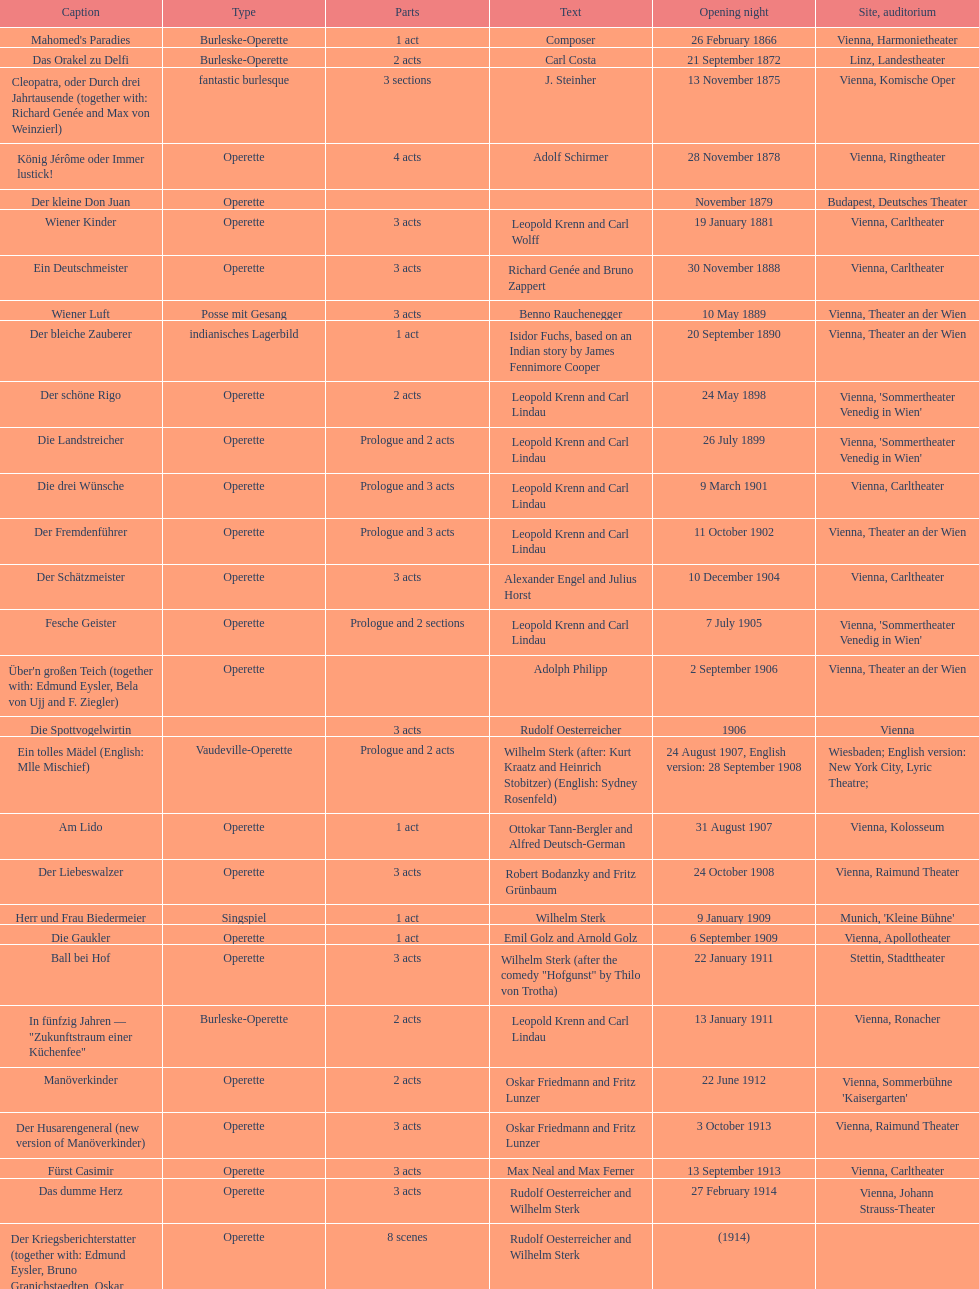Which genre is featured the most in this chart? Operette. Help me parse the entirety of this table. {'header': ['Caption', 'Type', 'Parts', 'Text', 'Opening night', 'Site, auditorium'], 'rows': [["Mahomed's Paradies", 'Burleske-Operette', '1 act', 'Composer', '26 February 1866', 'Vienna, Harmonietheater'], ['Das Orakel zu Delfi', 'Burleske-Operette', '2 acts', 'Carl Costa', '21 September 1872', 'Linz, Landestheater'], ['Cleopatra, oder Durch drei Jahrtausende (together with: Richard Genée and Max von Weinzierl)', 'fantastic burlesque', '3 sections', 'J. Steinher', '13 November 1875', 'Vienna, Komische Oper'], ['König Jérôme oder Immer lustick!', 'Operette', '4 acts', 'Adolf Schirmer', '28 November 1878', 'Vienna, Ringtheater'], ['Der kleine Don Juan', 'Operette', '', '', 'November 1879', 'Budapest, Deutsches Theater'], ['Wiener Kinder', 'Operette', '3 acts', 'Leopold Krenn and Carl Wolff', '19 January 1881', 'Vienna, Carltheater'], ['Ein Deutschmeister', 'Operette', '3 acts', 'Richard Genée and Bruno Zappert', '30 November 1888', 'Vienna, Carltheater'], ['Wiener Luft', 'Posse mit Gesang', '3 acts', 'Benno Rauchenegger', '10 May 1889', 'Vienna, Theater an der Wien'], ['Der bleiche Zauberer', 'indianisches Lagerbild', '1 act', 'Isidor Fuchs, based on an Indian story by James Fennimore Cooper', '20 September 1890', 'Vienna, Theater an der Wien'], ['Der schöne Rigo', 'Operette', '2 acts', 'Leopold Krenn and Carl Lindau', '24 May 1898', "Vienna, 'Sommertheater Venedig in Wien'"], ['Die Landstreicher', 'Operette', 'Prologue and 2 acts', 'Leopold Krenn and Carl Lindau', '26 July 1899', "Vienna, 'Sommertheater Venedig in Wien'"], ['Die drei Wünsche', 'Operette', 'Prologue and 3 acts', 'Leopold Krenn and Carl Lindau', '9 March 1901', 'Vienna, Carltheater'], ['Der Fremdenführer', 'Operette', 'Prologue and 3 acts', 'Leopold Krenn and Carl Lindau', '11 October 1902', 'Vienna, Theater an der Wien'], ['Der Schätzmeister', 'Operette', '3 acts', 'Alexander Engel and Julius Horst', '10 December 1904', 'Vienna, Carltheater'], ['Fesche Geister', 'Operette', 'Prologue and 2 sections', 'Leopold Krenn and Carl Lindau', '7 July 1905', "Vienna, 'Sommertheater Venedig in Wien'"], ["Über'n großen Teich (together with: Edmund Eysler, Bela von Ujj and F. Ziegler)", 'Operette', '', 'Adolph Philipp', '2 September 1906', 'Vienna, Theater an der Wien'], ['Die Spottvogelwirtin', '', '3 acts', 'Rudolf Oesterreicher', '1906', 'Vienna'], ['Ein tolles Mädel (English: Mlle Mischief)', 'Vaudeville-Operette', 'Prologue and 2 acts', 'Wilhelm Sterk (after: Kurt Kraatz and Heinrich Stobitzer) (English: Sydney Rosenfeld)', '24 August 1907, English version: 28 September 1908', 'Wiesbaden; English version: New York City, Lyric Theatre;'], ['Am Lido', 'Operette', '1 act', 'Ottokar Tann-Bergler and Alfred Deutsch-German', '31 August 1907', 'Vienna, Kolosseum'], ['Der Liebeswalzer', 'Operette', '3 acts', 'Robert Bodanzky and Fritz Grünbaum', '24 October 1908', 'Vienna, Raimund Theater'], ['Herr und Frau Biedermeier', 'Singspiel', '1 act', 'Wilhelm Sterk', '9 January 1909', "Munich, 'Kleine Bühne'"], ['Die Gaukler', 'Operette', '1 act', 'Emil Golz and Arnold Golz', '6 September 1909', 'Vienna, Apollotheater'], ['Ball bei Hof', 'Operette', '3 acts', 'Wilhelm Sterk (after the comedy "Hofgunst" by Thilo von Trotha)', '22 January 1911', 'Stettin, Stadttheater'], ['In fünfzig Jahren — "Zukunftstraum einer Küchenfee"', 'Burleske-Operette', '2 acts', 'Leopold Krenn and Carl Lindau', '13 January 1911', 'Vienna, Ronacher'], ['Manöverkinder', 'Operette', '2 acts', 'Oskar Friedmann and Fritz Lunzer', '22 June 1912', "Vienna, Sommerbühne 'Kaisergarten'"], ['Der Husarengeneral (new version of Manöverkinder)', 'Operette', '3 acts', 'Oskar Friedmann and Fritz Lunzer', '3 October 1913', 'Vienna, Raimund Theater'], ['Fürst Casimir', 'Operette', '3 acts', 'Max Neal and Max Ferner', '13 September 1913', 'Vienna, Carltheater'], ['Das dumme Herz', 'Operette', '3 acts', 'Rudolf Oesterreicher and Wilhelm Sterk', '27 February 1914', 'Vienna, Johann Strauss-Theater'], ['Der Kriegsberichterstatter (together with: Edmund Eysler, Bruno Granichstaedten, Oskar Nedbal, Charles Weinberger)', 'Operette', '8 scenes', 'Rudolf Oesterreicher and Wilhelm Sterk', '(1914)', ''], ['Im siebenten Himmel', 'Operette', '3 acts', 'Max Neal and Max Ferner', '26 February 1916', 'Munich, Theater am Gärtnerplatz'], ['Deutschmeisterkapelle', 'Operette', '', 'Hubert Marischka and Rudolf Oesterreicher', '30 May 1958', 'Vienna, Raimund Theater'], ['Die verliebte Eskadron', 'Operette', '3 acts', 'Wilhelm Sterk (after B. Buchbinder)', '11 July 1930', 'Vienna, Johann-Strauß-Theater']]} 